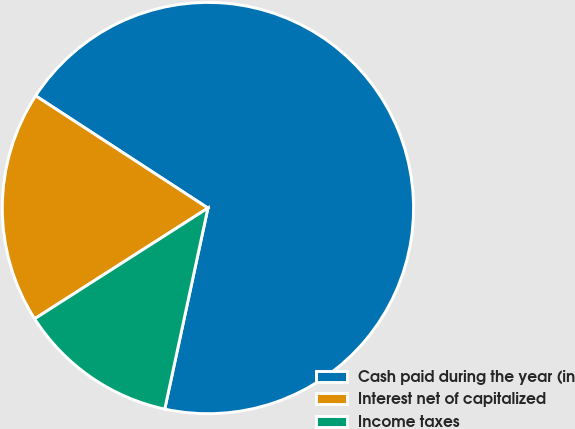Convert chart to OTSL. <chart><loc_0><loc_0><loc_500><loc_500><pie_chart><fcel>Cash paid during the year (in<fcel>Interest net of capitalized<fcel>Income taxes<nl><fcel>69.17%<fcel>18.24%<fcel>12.58%<nl></chart> 